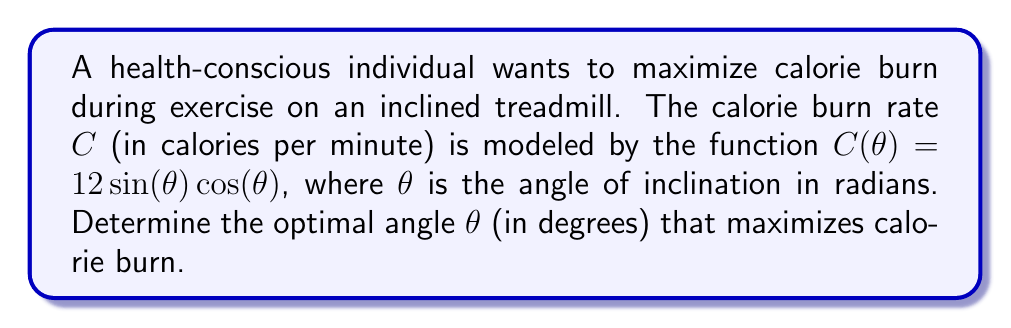What is the answer to this math problem? To find the optimal angle, we need to follow these steps:

1) First, we need to find the derivative of $C(\theta)$ with respect to $\theta$:

   $$\frac{dC}{d\theta} = 12[\cos^2(\theta) - \sin^2(\theta)]$$

   This is derived using the product rule and the derivatives of sine and cosine.

2) To find the maximum, we set the derivative equal to zero:

   $$12[\cos^2(\theta) - \sin^2(\theta)] = 0$$

3) Simplify:

   $$\cos^2(\theta) - \sin^2(\theta) = 0$$

4) Recall the trigonometric identity $\cos(2\theta) = \cos^2(\theta) - \sin^2(\theta)$:

   $$\cos(2\theta) = 0$$

5) Solve for $\theta$:

   $$2\theta = \frac{\pi}{2} \text{ or } \frac{3\pi}{2}$$
   
   $$\theta = \frac{\pi}{4} \text{ or } \frac{3\pi}{4}$$

6) The second derivative test confirms that $\frac{\pi}{4}$ gives a maximum.

7) Convert radians to degrees:

   $$\frac{\pi}{4} \text{ radians} = 45°$$

Therefore, the optimal angle for maximum calorie burn is 45°.
Answer: 45° 